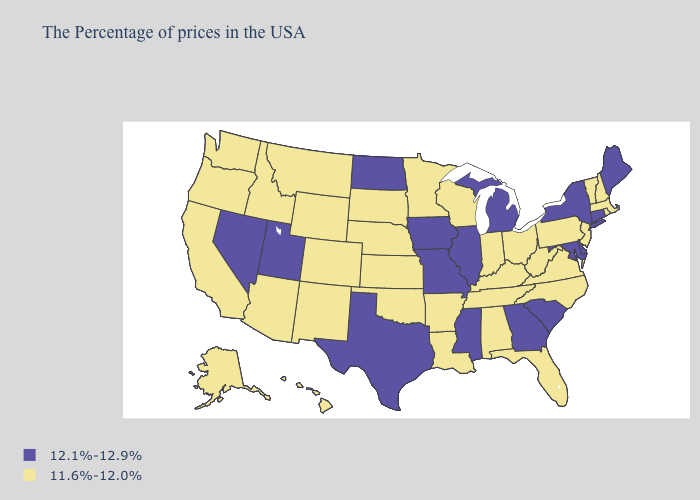Does the first symbol in the legend represent the smallest category?
Concise answer only. No. Name the states that have a value in the range 12.1%-12.9%?
Answer briefly. Maine, Connecticut, New York, Delaware, Maryland, South Carolina, Georgia, Michigan, Illinois, Mississippi, Missouri, Iowa, Texas, North Dakota, Utah, Nevada. What is the value of Illinois?
Answer briefly. 12.1%-12.9%. Among the states that border Alabama , does Florida have the highest value?
Give a very brief answer. No. What is the value of Alabama?
Short answer required. 11.6%-12.0%. What is the lowest value in states that border Nevada?
Concise answer only. 11.6%-12.0%. What is the value of Maine?
Write a very short answer. 12.1%-12.9%. Which states have the lowest value in the Northeast?
Answer briefly. Massachusetts, Rhode Island, New Hampshire, Vermont, New Jersey, Pennsylvania. What is the value of Indiana?
Quick response, please. 11.6%-12.0%. Which states hav the highest value in the West?
Quick response, please. Utah, Nevada. What is the value of Delaware?
Short answer required. 12.1%-12.9%. Does the first symbol in the legend represent the smallest category?
Be succinct. No. Does Florida have a higher value than Kansas?
Give a very brief answer. No. Does the first symbol in the legend represent the smallest category?
Keep it brief. No. Among the states that border Iowa , does Nebraska have the lowest value?
Give a very brief answer. Yes. 